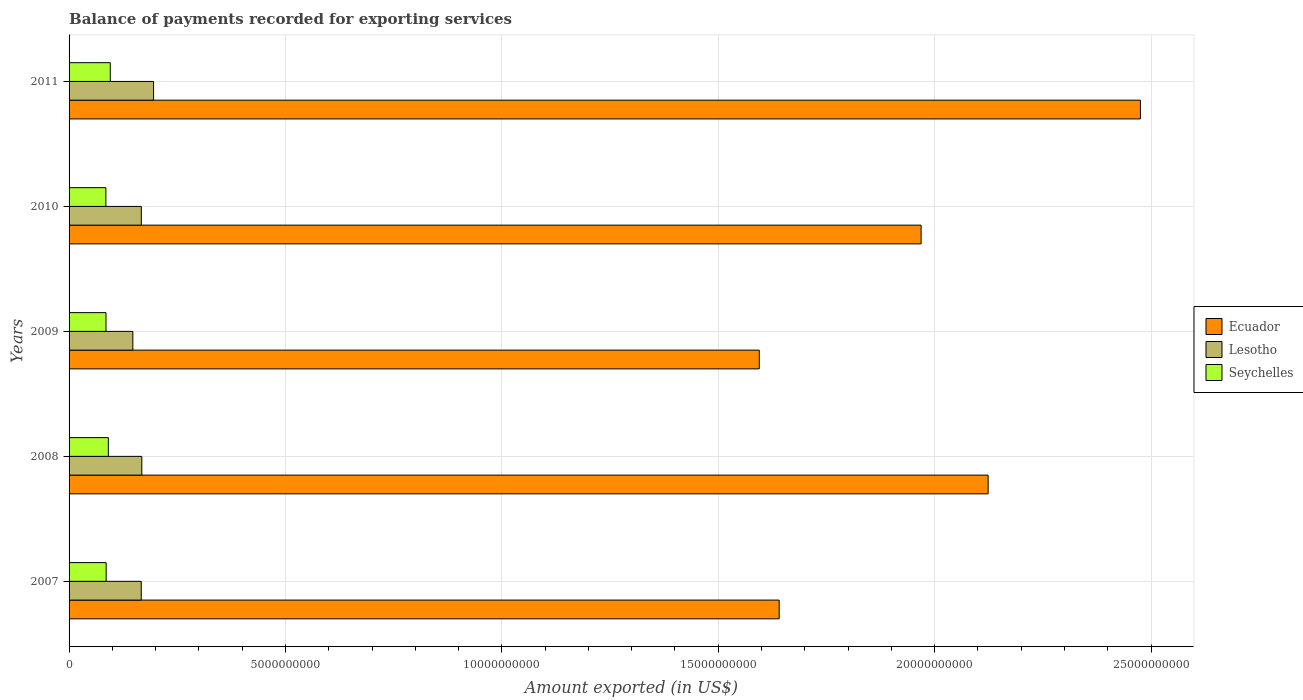How many bars are there on the 4th tick from the top?
Ensure brevity in your answer.  3. How many bars are there on the 5th tick from the bottom?
Your response must be concise. 3. What is the label of the 2nd group of bars from the top?
Offer a terse response. 2010. What is the amount exported in Seychelles in 2010?
Offer a very short reply. 8.50e+08. Across all years, what is the maximum amount exported in Ecuador?
Your answer should be compact. 2.48e+1. Across all years, what is the minimum amount exported in Lesotho?
Offer a very short reply. 1.47e+09. In which year was the amount exported in Ecuador maximum?
Offer a very short reply. 2011. In which year was the amount exported in Lesotho minimum?
Your response must be concise. 2009. What is the total amount exported in Ecuador in the graph?
Offer a terse response. 9.80e+1. What is the difference between the amount exported in Seychelles in 2008 and that in 2011?
Make the answer very short. -4.55e+07. What is the difference between the amount exported in Lesotho in 2009 and the amount exported in Ecuador in 2007?
Offer a terse response. -1.49e+1. What is the average amount exported in Lesotho per year?
Offer a terse response. 1.69e+09. In the year 2008, what is the difference between the amount exported in Seychelles and amount exported in Lesotho?
Make the answer very short. -7.74e+08. In how many years, is the amount exported in Seychelles greater than 12000000000 US$?
Ensure brevity in your answer.  0. What is the ratio of the amount exported in Lesotho in 2007 to that in 2010?
Provide a succinct answer. 1. Is the difference between the amount exported in Seychelles in 2007 and 2009 greater than the difference between the amount exported in Lesotho in 2007 and 2009?
Offer a terse response. No. What is the difference between the highest and the second highest amount exported in Ecuador?
Provide a succinct answer. 3.52e+09. What is the difference between the highest and the lowest amount exported in Lesotho?
Your answer should be compact. 4.79e+08. In how many years, is the amount exported in Seychelles greater than the average amount exported in Seychelles taken over all years?
Make the answer very short. 2. Is the sum of the amount exported in Seychelles in 2009 and 2011 greater than the maximum amount exported in Ecuador across all years?
Keep it short and to the point. No. What does the 1st bar from the top in 2007 represents?
Offer a terse response. Seychelles. What does the 2nd bar from the bottom in 2010 represents?
Offer a very short reply. Lesotho. Is it the case that in every year, the sum of the amount exported in Ecuador and amount exported in Seychelles is greater than the amount exported in Lesotho?
Offer a very short reply. Yes. How many bars are there?
Your answer should be very brief. 15. How many years are there in the graph?
Provide a short and direct response. 5. What is the difference between two consecutive major ticks on the X-axis?
Ensure brevity in your answer.  5.00e+09. Are the values on the major ticks of X-axis written in scientific E-notation?
Provide a succinct answer. No. Does the graph contain any zero values?
Offer a terse response. No. Where does the legend appear in the graph?
Provide a succinct answer. Center right. How many legend labels are there?
Ensure brevity in your answer.  3. How are the legend labels stacked?
Make the answer very short. Vertical. What is the title of the graph?
Keep it short and to the point. Balance of payments recorded for exporting services. Does "Tanzania" appear as one of the legend labels in the graph?
Offer a terse response. No. What is the label or title of the X-axis?
Provide a short and direct response. Amount exported (in US$). What is the label or title of the Y-axis?
Your answer should be very brief. Years. What is the Amount exported (in US$) in Ecuador in 2007?
Give a very brief answer. 1.64e+1. What is the Amount exported (in US$) of Lesotho in 2007?
Provide a short and direct response. 1.67e+09. What is the Amount exported (in US$) of Seychelles in 2007?
Provide a short and direct response. 8.57e+08. What is the Amount exported (in US$) in Ecuador in 2008?
Make the answer very short. 2.12e+1. What is the Amount exported (in US$) of Lesotho in 2008?
Your response must be concise. 1.68e+09. What is the Amount exported (in US$) of Seychelles in 2008?
Ensure brevity in your answer.  9.07e+08. What is the Amount exported (in US$) in Ecuador in 2009?
Ensure brevity in your answer.  1.59e+1. What is the Amount exported (in US$) of Lesotho in 2009?
Provide a short and direct response. 1.47e+09. What is the Amount exported (in US$) of Seychelles in 2009?
Offer a terse response. 8.53e+08. What is the Amount exported (in US$) of Ecuador in 2010?
Your answer should be very brief. 1.97e+1. What is the Amount exported (in US$) of Lesotho in 2010?
Your response must be concise. 1.67e+09. What is the Amount exported (in US$) in Seychelles in 2010?
Provide a succinct answer. 8.50e+08. What is the Amount exported (in US$) of Ecuador in 2011?
Offer a terse response. 2.48e+1. What is the Amount exported (in US$) in Lesotho in 2011?
Provide a short and direct response. 1.95e+09. What is the Amount exported (in US$) in Seychelles in 2011?
Offer a terse response. 9.52e+08. Across all years, what is the maximum Amount exported (in US$) in Ecuador?
Ensure brevity in your answer.  2.48e+1. Across all years, what is the maximum Amount exported (in US$) of Lesotho?
Provide a short and direct response. 1.95e+09. Across all years, what is the maximum Amount exported (in US$) in Seychelles?
Provide a succinct answer. 9.52e+08. Across all years, what is the minimum Amount exported (in US$) in Ecuador?
Keep it short and to the point. 1.59e+1. Across all years, what is the minimum Amount exported (in US$) of Lesotho?
Ensure brevity in your answer.  1.47e+09. Across all years, what is the minimum Amount exported (in US$) in Seychelles?
Make the answer very short. 8.50e+08. What is the total Amount exported (in US$) of Ecuador in the graph?
Make the answer very short. 9.80e+1. What is the total Amount exported (in US$) of Lesotho in the graph?
Offer a very short reply. 8.44e+09. What is the total Amount exported (in US$) of Seychelles in the graph?
Ensure brevity in your answer.  4.42e+09. What is the difference between the Amount exported (in US$) of Ecuador in 2007 and that in 2008?
Keep it short and to the point. -4.83e+09. What is the difference between the Amount exported (in US$) in Lesotho in 2007 and that in 2008?
Provide a succinct answer. -1.31e+07. What is the difference between the Amount exported (in US$) of Seychelles in 2007 and that in 2008?
Provide a short and direct response. -4.96e+07. What is the difference between the Amount exported (in US$) in Ecuador in 2007 and that in 2009?
Provide a short and direct response. 4.60e+08. What is the difference between the Amount exported (in US$) of Lesotho in 2007 and that in 2009?
Make the answer very short. 1.94e+08. What is the difference between the Amount exported (in US$) in Seychelles in 2007 and that in 2009?
Offer a very short reply. 3.87e+06. What is the difference between the Amount exported (in US$) in Ecuador in 2007 and that in 2010?
Your response must be concise. -3.28e+09. What is the difference between the Amount exported (in US$) of Lesotho in 2007 and that in 2010?
Ensure brevity in your answer.  -1.52e+06. What is the difference between the Amount exported (in US$) in Seychelles in 2007 and that in 2010?
Make the answer very short. 6.99e+06. What is the difference between the Amount exported (in US$) in Ecuador in 2007 and that in 2011?
Make the answer very short. -8.35e+09. What is the difference between the Amount exported (in US$) of Lesotho in 2007 and that in 2011?
Keep it short and to the point. -2.85e+08. What is the difference between the Amount exported (in US$) of Seychelles in 2007 and that in 2011?
Offer a very short reply. -9.51e+07. What is the difference between the Amount exported (in US$) in Ecuador in 2008 and that in 2009?
Offer a very short reply. 5.29e+09. What is the difference between the Amount exported (in US$) in Lesotho in 2008 and that in 2009?
Keep it short and to the point. 2.07e+08. What is the difference between the Amount exported (in US$) in Seychelles in 2008 and that in 2009?
Your response must be concise. 5.35e+07. What is the difference between the Amount exported (in US$) in Ecuador in 2008 and that in 2010?
Offer a terse response. 1.55e+09. What is the difference between the Amount exported (in US$) of Lesotho in 2008 and that in 2010?
Offer a very short reply. 1.16e+07. What is the difference between the Amount exported (in US$) of Seychelles in 2008 and that in 2010?
Your response must be concise. 5.66e+07. What is the difference between the Amount exported (in US$) in Ecuador in 2008 and that in 2011?
Your answer should be compact. -3.52e+09. What is the difference between the Amount exported (in US$) in Lesotho in 2008 and that in 2011?
Ensure brevity in your answer.  -2.72e+08. What is the difference between the Amount exported (in US$) in Seychelles in 2008 and that in 2011?
Offer a very short reply. -4.55e+07. What is the difference between the Amount exported (in US$) in Ecuador in 2009 and that in 2010?
Ensure brevity in your answer.  -3.74e+09. What is the difference between the Amount exported (in US$) of Lesotho in 2009 and that in 2010?
Make the answer very short. -1.96e+08. What is the difference between the Amount exported (in US$) in Seychelles in 2009 and that in 2010?
Offer a terse response. 3.12e+06. What is the difference between the Amount exported (in US$) of Ecuador in 2009 and that in 2011?
Offer a very short reply. -8.81e+09. What is the difference between the Amount exported (in US$) of Lesotho in 2009 and that in 2011?
Your response must be concise. -4.79e+08. What is the difference between the Amount exported (in US$) in Seychelles in 2009 and that in 2011?
Your answer should be compact. -9.90e+07. What is the difference between the Amount exported (in US$) of Ecuador in 2010 and that in 2011?
Offer a terse response. -5.07e+09. What is the difference between the Amount exported (in US$) in Lesotho in 2010 and that in 2011?
Provide a succinct answer. -2.83e+08. What is the difference between the Amount exported (in US$) of Seychelles in 2010 and that in 2011?
Your answer should be compact. -1.02e+08. What is the difference between the Amount exported (in US$) of Ecuador in 2007 and the Amount exported (in US$) of Lesotho in 2008?
Your response must be concise. 1.47e+1. What is the difference between the Amount exported (in US$) of Ecuador in 2007 and the Amount exported (in US$) of Seychelles in 2008?
Keep it short and to the point. 1.55e+1. What is the difference between the Amount exported (in US$) in Lesotho in 2007 and the Amount exported (in US$) in Seychelles in 2008?
Your response must be concise. 7.61e+08. What is the difference between the Amount exported (in US$) in Ecuador in 2007 and the Amount exported (in US$) in Lesotho in 2009?
Provide a succinct answer. 1.49e+1. What is the difference between the Amount exported (in US$) in Ecuador in 2007 and the Amount exported (in US$) in Seychelles in 2009?
Offer a terse response. 1.56e+1. What is the difference between the Amount exported (in US$) in Lesotho in 2007 and the Amount exported (in US$) in Seychelles in 2009?
Your answer should be very brief. 8.14e+08. What is the difference between the Amount exported (in US$) of Ecuador in 2007 and the Amount exported (in US$) of Lesotho in 2010?
Offer a terse response. 1.47e+1. What is the difference between the Amount exported (in US$) in Ecuador in 2007 and the Amount exported (in US$) in Seychelles in 2010?
Keep it short and to the point. 1.56e+1. What is the difference between the Amount exported (in US$) of Lesotho in 2007 and the Amount exported (in US$) of Seychelles in 2010?
Give a very brief answer. 8.17e+08. What is the difference between the Amount exported (in US$) in Ecuador in 2007 and the Amount exported (in US$) in Lesotho in 2011?
Offer a very short reply. 1.45e+1. What is the difference between the Amount exported (in US$) in Ecuador in 2007 and the Amount exported (in US$) in Seychelles in 2011?
Provide a short and direct response. 1.55e+1. What is the difference between the Amount exported (in US$) in Lesotho in 2007 and the Amount exported (in US$) in Seychelles in 2011?
Ensure brevity in your answer.  7.15e+08. What is the difference between the Amount exported (in US$) of Ecuador in 2008 and the Amount exported (in US$) of Lesotho in 2009?
Ensure brevity in your answer.  1.98e+1. What is the difference between the Amount exported (in US$) of Ecuador in 2008 and the Amount exported (in US$) of Seychelles in 2009?
Keep it short and to the point. 2.04e+1. What is the difference between the Amount exported (in US$) in Lesotho in 2008 and the Amount exported (in US$) in Seychelles in 2009?
Your response must be concise. 8.27e+08. What is the difference between the Amount exported (in US$) in Ecuador in 2008 and the Amount exported (in US$) in Lesotho in 2010?
Offer a terse response. 1.96e+1. What is the difference between the Amount exported (in US$) of Ecuador in 2008 and the Amount exported (in US$) of Seychelles in 2010?
Give a very brief answer. 2.04e+1. What is the difference between the Amount exported (in US$) in Lesotho in 2008 and the Amount exported (in US$) in Seychelles in 2010?
Give a very brief answer. 8.31e+08. What is the difference between the Amount exported (in US$) of Ecuador in 2008 and the Amount exported (in US$) of Lesotho in 2011?
Offer a very short reply. 1.93e+1. What is the difference between the Amount exported (in US$) of Ecuador in 2008 and the Amount exported (in US$) of Seychelles in 2011?
Keep it short and to the point. 2.03e+1. What is the difference between the Amount exported (in US$) in Lesotho in 2008 and the Amount exported (in US$) in Seychelles in 2011?
Give a very brief answer. 7.28e+08. What is the difference between the Amount exported (in US$) of Ecuador in 2009 and the Amount exported (in US$) of Lesotho in 2010?
Offer a terse response. 1.43e+1. What is the difference between the Amount exported (in US$) in Ecuador in 2009 and the Amount exported (in US$) in Seychelles in 2010?
Keep it short and to the point. 1.51e+1. What is the difference between the Amount exported (in US$) of Lesotho in 2009 and the Amount exported (in US$) of Seychelles in 2010?
Ensure brevity in your answer.  6.23e+08. What is the difference between the Amount exported (in US$) in Ecuador in 2009 and the Amount exported (in US$) in Lesotho in 2011?
Keep it short and to the point. 1.40e+1. What is the difference between the Amount exported (in US$) of Ecuador in 2009 and the Amount exported (in US$) of Seychelles in 2011?
Your answer should be very brief. 1.50e+1. What is the difference between the Amount exported (in US$) of Lesotho in 2009 and the Amount exported (in US$) of Seychelles in 2011?
Keep it short and to the point. 5.21e+08. What is the difference between the Amount exported (in US$) of Ecuador in 2010 and the Amount exported (in US$) of Lesotho in 2011?
Offer a terse response. 1.77e+1. What is the difference between the Amount exported (in US$) of Ecuador in 2010 and the Amount exported (in US$) of Seychelles in 2011?
Your response must be concise. 1.87e+1. What is the difference between the Amount exported (in US$) of Lesotho in 2010 and the Amount exported (in US$) of Seychelles in 2011?
Keep it short and to the point. 7.17e+08. What is the average Amount exported (in US$) in Ecuador per year?
Ensure brevity in your answer.  1.96e+1. What is the average Amount exported (in US$) of Lesotho per year?
Provide a succinct answer. 1.69e+09. What is the average Amount exported (in US$) in Seychelles per year?
Offer a very short reply. 8.84e+08. In the year 2007, what is the difference between the Amount exported (in US$) in Ecuador and Amount exported (in US$) in Lesotho?
Offer a terse response. 1.47e+1. In the year 2007, what is the difference between the Amount exported (in US$) of Ecuador and Amount exported (in US$) of Seychelles?
Give a very brief answer. 1.56e+1. In the year 2007, what is the difference between the Amount exported (in US$) of Lesotho and Amount exported (in US$) of Seychelles?
Your answer should be compact. 8.10e+08. In the year 2008, what is the difference between the Amount exported (in US$) of Ecuador and Amount exported (in US$) of Lesotho?
Offer a very short reply. 1.96e+1. In the year 2008, what is the difference between the Amount exported (in US$) in Ecuador and Amount exported (in US$) in Seychelles?
Your response must be concise. 2.03e+1. In the year 2008, what is the difference between the Amount exported (in US$) in Lesotho and Amount exported (in US$) in Seychelles?
Give a very brief answer. 7.74e+08. In the year 2009, what is the difference between the Amount exported (in US$) in Ecuador and Amount exported (in US$) in Lesotho?
Make the answer very short. 1.45e+1. In the year 2009, what is the difference between the Amount exported (in US$) of Ecuador and Amount exported (in US$) of Seychelles?
Ensure brevity in your answer.  1.51e+1. In the year 2009, what is the difference between the Amount exported (in US$) of Lesotho and Amount exported (in US$) of Seychelles?
Your response must be concise. 6.20e+08. In the year 2010, what is the difference between the Amount exported (in US$) in Ecuador and Amount exported (in US$) in Lesotho?
Offer a very short reply. 1.80e+1. In the year 2010, what is the difference between the Amount exported (in US$) of Ecuador and Amount exported (in US$) of Seychelles?
Provide a short and direct response. 1.88e+1. In the year 2010, what is the difference between the Amount exported (in US$) of Lesotho and Amount exported (in US$) of Seychelles?
Provide a short and direct response. 8.19e+08. In the year 2011, what is the difference between the Amount exported (in US$) of Ecuador and Amount exported (in US$) of Lesotho?
Give a very brief answer. 2.28e+1. In the year 2011, what is the difference between the Amount exported (in US$) of Ecuador and Amount exported (in US$) of Seychelles?
Your answer should be very brief. 2.38e+1. In the year 2011, what is the difference between the Amount exported (in US$) in Lesotho and Amount exported (in US$) in Seychelles?
Give a very brief answer. 1.00e+09. What is the ratio of the Amount exported (in US$) in Ecuador in 2007 to that in 2008?
Give a very brief answer. 0.77. What is the ratio of the Amount exported (in US$) of Lesotho in 2007 to that in 2008?
Make the answer very short. 0.99. What is the ratio of the Amount exported (in US$) in Seychelles in 2007 to that in 2008?
Your answer should be very brief. 0.95. What is the ratio of the Amount exported (in US$) of Ecuador in 2007 to that in 2009?
Your response must be concise. 1.03. What is the ratio of the Amount exported (in US$) in Lesotho in 2007 to that in 2009?
Offer a terse response. 1.13. What is the ratio of the Amount exported (in US$) of Ecuador in 2007 to that in 2010?
Give a very brief answer. 0.83. What is the ratio of the Amount exported (in US$) of Lesotho in 2007 to that in 2010?
Your answer should be compact. 1. What is the ratio of the Amount exported (in US$) of Seychelles in 2007 to that in 2010?
Offer a very short reply. 1.01. What is the ratio of the Amount exported (in US$) in Ecuador in 2007 to that in 2011?
Your answer should be compact. 0.66. What is the ratio of the Amount exported (in US$) of Lesotho in 2007 to that in 2011?
Provide a short and direct response. 0.85. What is the ratio of the Amount exported (in US$) of Seychelles in 2007 to that in 2011?
Provide a succinct answer. 0.9. What is the ratio of the Amount exported (in US$) of Ecuador in 2008 to that in 2009?
Offer a terse response. 1.33. What is the ratio of the Amount exported (in US$) of Lesotho in 2008 to that in 2009?
Make the answer very short. 1.14. What is the ratio of the Amount exported (in US$) in Seychelles in 2008 to that in 2009?
Your response must be concise. 1.06. What is the ratio of the Amount exported (in US$) of Ecuador in 2008 to that in 2010?
Your response must be concise. 1.08. What is the ratio of the Amount exported (in US$) of Lesotho in 2008 to that in 2010?
Provide a succinct answer. 1.01. What is the ratio of the Amount exported (in US$) of Seychelles in 2008 to that in 2010?
Offer a terse response. 1.07. What is the ratio of the Amount exported (in US$) in Ecuador in 2008 to that in 2011?
Provide a succinct answer. 0.86. What is the ratio of the Amount exported (in US$) in Lesotho in 2008 to that in 2011?
Your answer should be very brief. 0.86. What is the ratio of the Amount exported (in US$) in Seychelles in 2008 to that in 2011?
Keep it short and to the point. 0.95. What is the ratio of the Amount exported (in US$) of Ecuador in 2009 to that in 2010?
Your answer should be compact. 0.81. What is the ratio of the Amount exported (in US$) in Lesotho in 2009 to that in 2010?
Your response must be concise. 0.88. What is the ratio of the Amount exported (in US$) in Seychelles in 2009 to that in 2010?
Provide a succinct answer. 1. What is the ratio of the Amount exported (in US$) of Ecuador in 2009 to that in 2011?
Make the answer very short. 0.64. What is the ratio of the Amount exported (in US$) of Lesotho in 2009 to that in 2011?
Your response must be concise. 0.75. What is the ratio of the Amount exported (in US$) of Seychelles in 2009 to that in 2011?
Keep it short and to the point. 0.9. What is the ratio of the Amount exported (in US$) in Ecuador in 2010 to that in 2011?
Provide a succinct answer. 0.8. What is the ratio of the Amount exported (in US$) of Lesotho in 2010 to that in 2011?
Offer a very short reply. 0.85. What is the ratio of the Amount exported (in US$) of Seychelles in 2010 to that in 2011?
Provide a short and direct response. 0.89. What is the difference between the highest and the second highest Amount exported (in US$) of Ecuador?
Your response must be concise. 3.52e+09. What is the difference between the highest and the second highest Amount exported (in US$) in Lesotho?
Your answer should be compact. 2.72e+08. What is the difference between the highest and the second highest Amount exported (in US$) in Seychelles?
Your answer should be very brief. 4.55e+07. What is the difference between the highest and the lowest Amount exported (in US$) of Ecuador?
Ensure brevity in your answer.  8.81e+09. What is the difference between the highest and the lowest Amount exported (in US$) of Lesotho?
Offer a very short reply. 4.79e+08. What is the difference between the highest and the lowest Amount exported (in US$) of Seychelles?
Provide a short and direct response. 1.02e+08. 